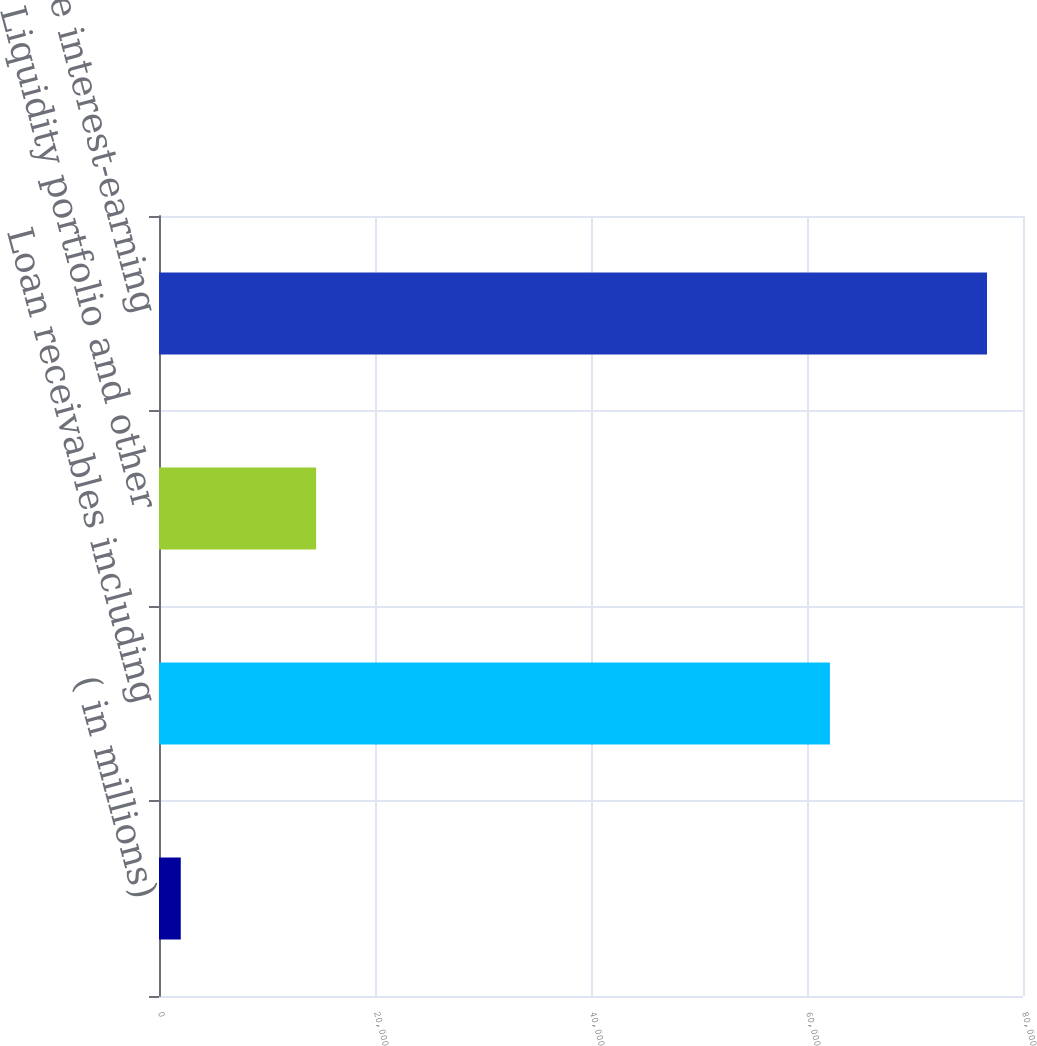Convert chart to OTSL. <chart><loc_0><loc_0><loc_500><loc_500><bar_chart><fcel>( in millions)<fcel>Loan receivables including<fcel>Liquidity portfolio and other<fcel>Total average interest-earning<nl><fcel>2015<fcel>62120<fcel>14548<fcel>76668<nl></chart> 